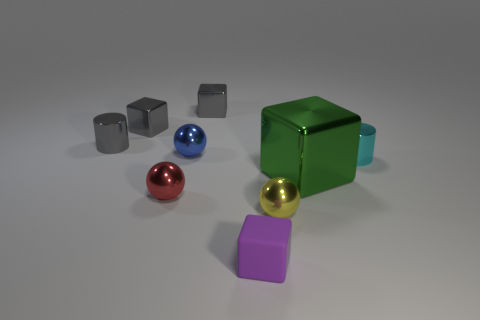Add 1 tiny gray metallic cylinders. How many objects exist? 10 Subtract all blocks. How many objects are left? 5 Add 6 green shiny blocks. How many green shiny blocks exist? 7 Subtract 0 brown cubes. How many objects are left? 9 Subtract all gray cubes. Subtract all small cyan metallic cylinders. How many objects are left? 6 Add 2 yellow things. How many yellow things are left? 3 